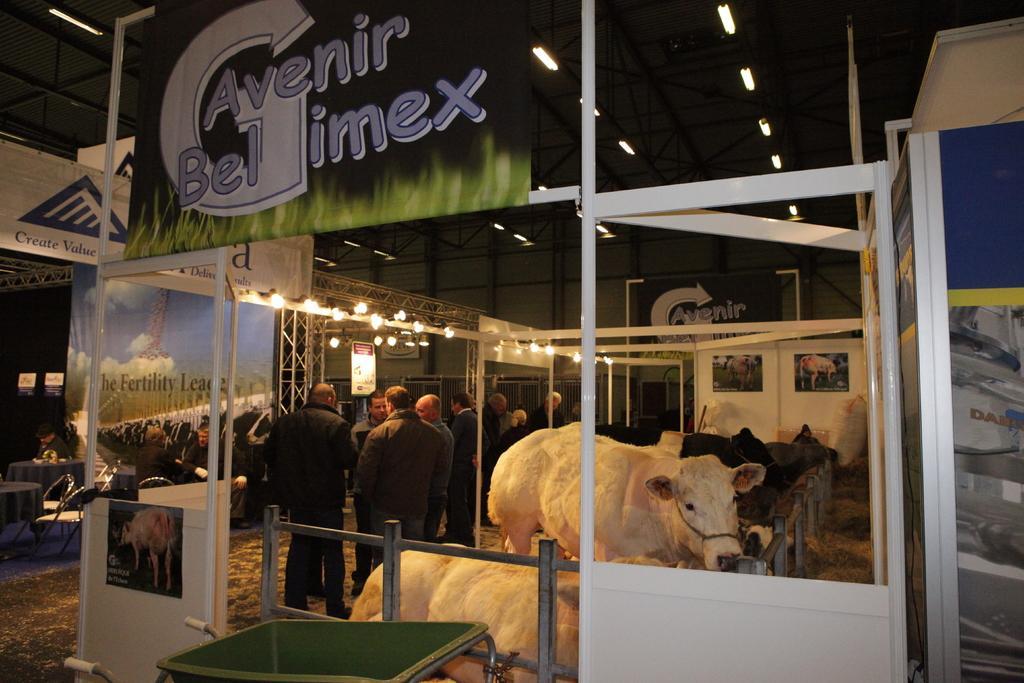How would you summarize this image in a sentence or two? In this image in the front there is a table which is green in colour. In the center there is a fence and there are animals standing and sitting and on the left side there are persons standing and sitting. On the top there lights and there are boards with some text written on it. 